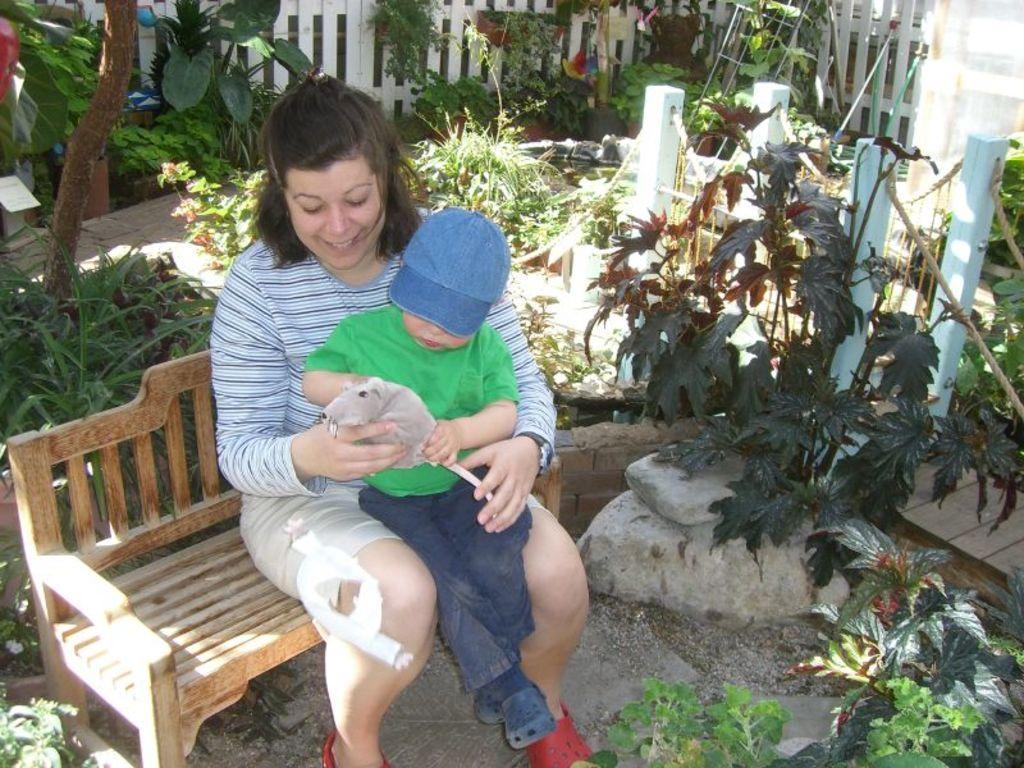Please provide a concise description of this image. A woman is sitting on a bench. A kid is sitting on her lap wears Green t shirt and blue pant. He is playing with a toy in his hand. He wears a cap. They are sitting in a garden with few plants. There is a barrier at a distance. 